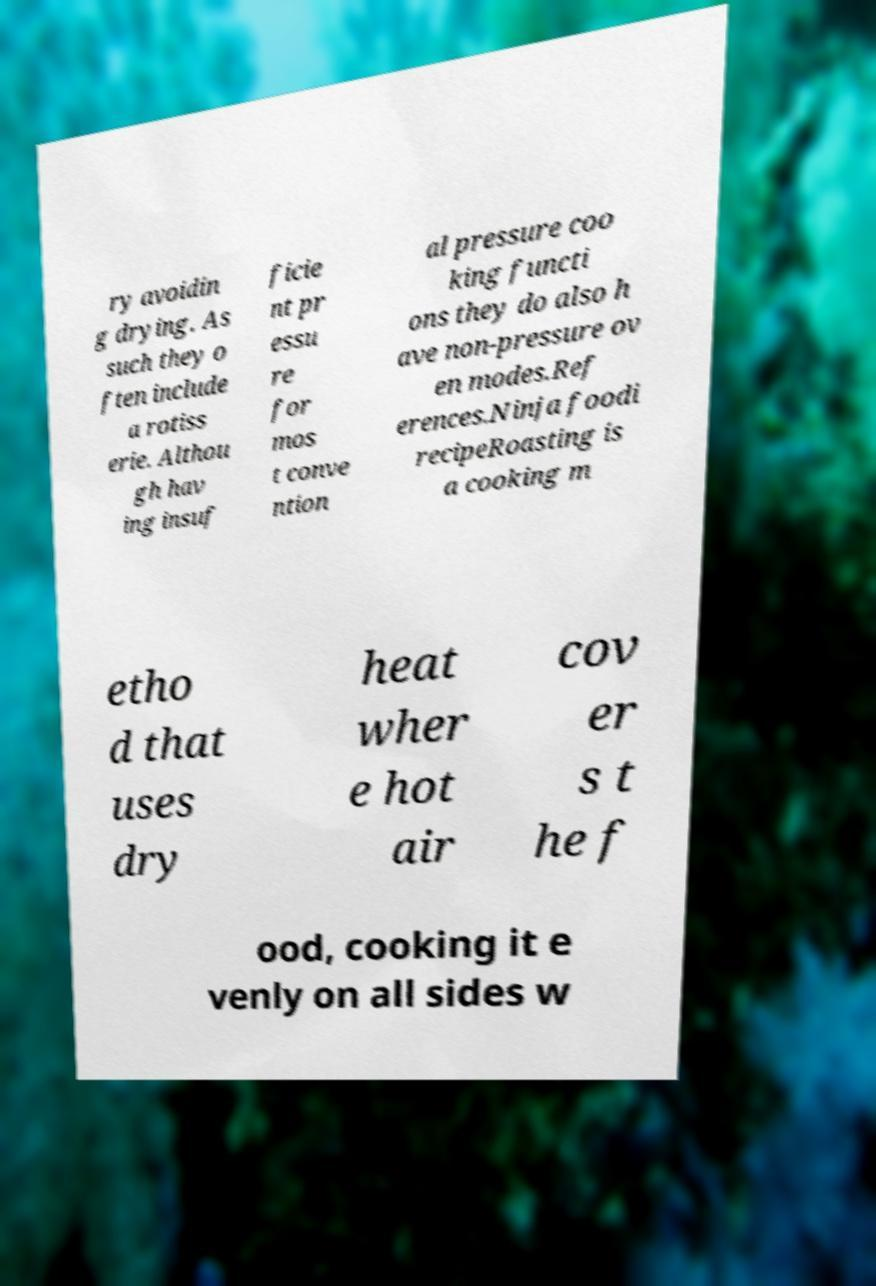What messages or text are displayed in this image? I need them in a readable, typed format. ry avoidin g drying. As such they o ften include a rotiss erie. Althou gh hav ing insuf ficie nt pr essu re for mos t conve ntion al pressure coo king functi ons they do also h ave non-pressure ov en modes.Ref erences.Ninja foodi recipeRoasting is a cooking m etho d that uses dry heat wher e hot air cov er s t he f ood, cooking it e venly on all sides w 